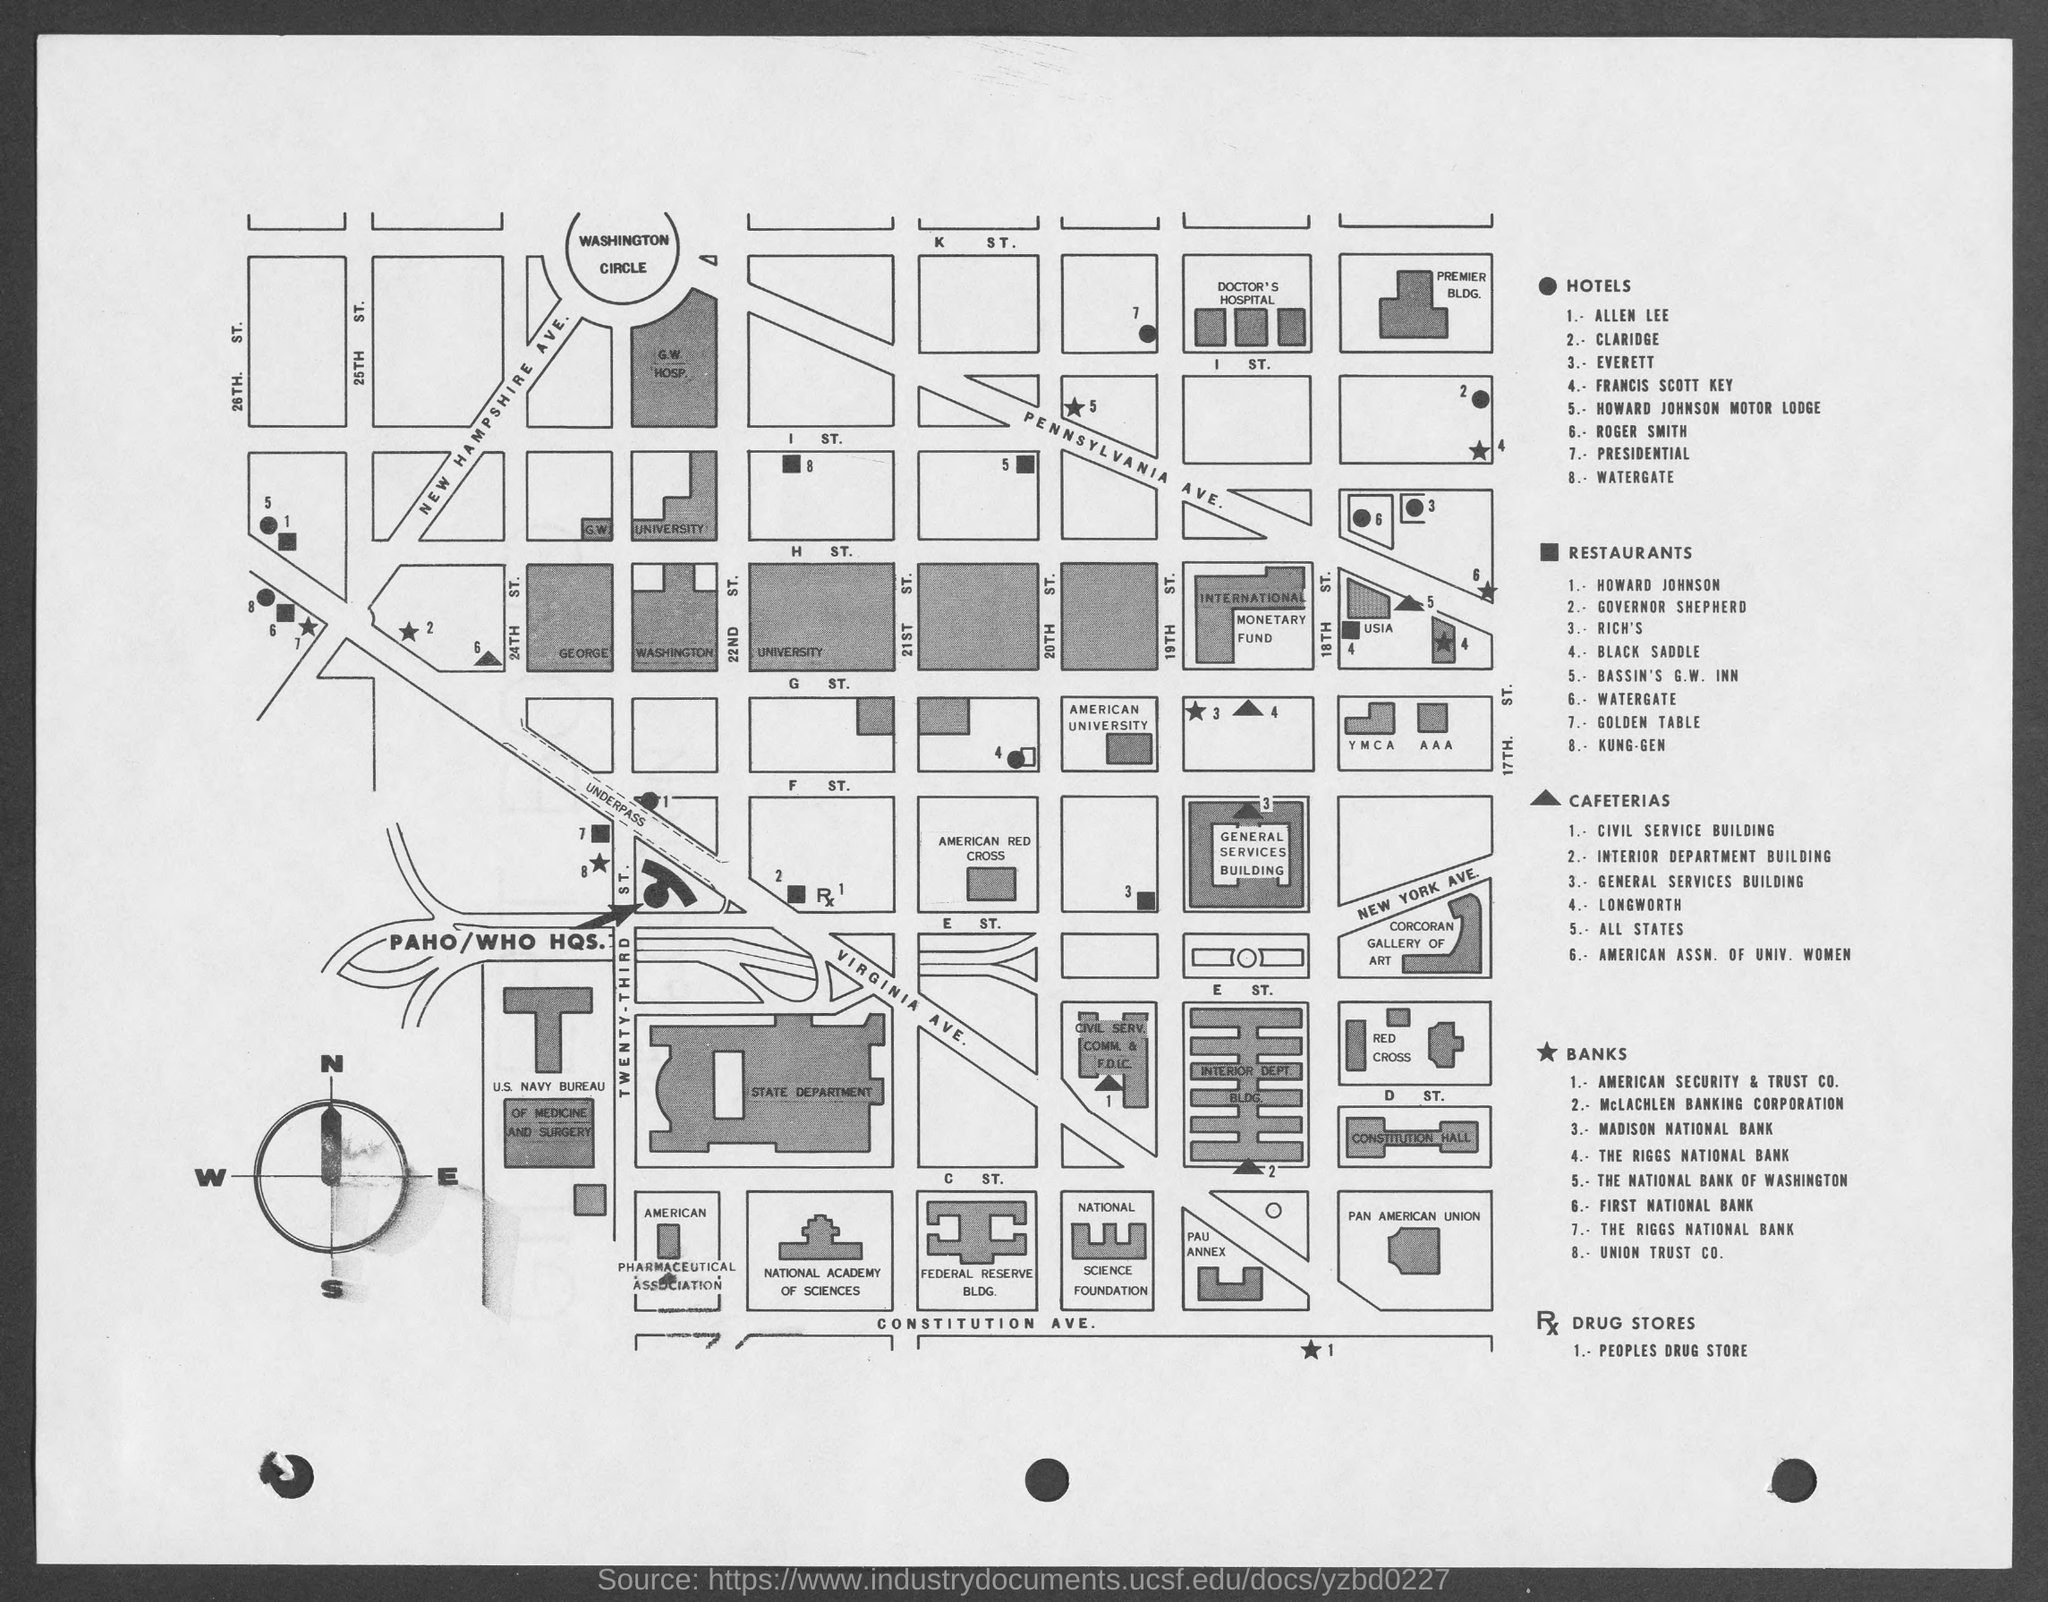Highlight a few significant elements in this photo. There are six cafeterias. There are 8 restaurants. The name of the drug store is People's Drug Store. There are 8 hotels. There are eight banks in total. 